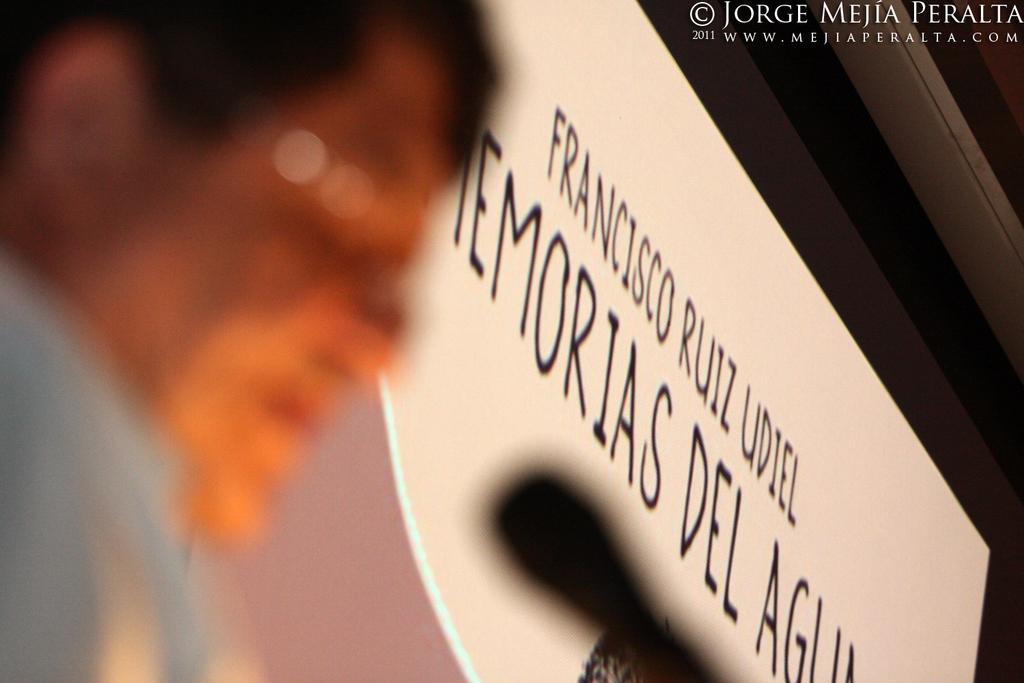How would you summarize this image in a sentence or two? On the left side of this image I can see a person. In front of this person there is a mike. In the background there is a white color board on which I can see some text in black color. On the right top of the image I can see some text. 